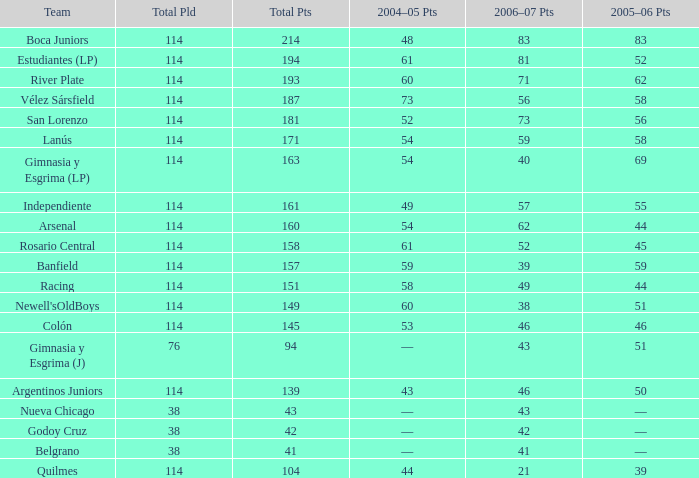What is the total number of PLD for Team Arsenal? 1.0. 